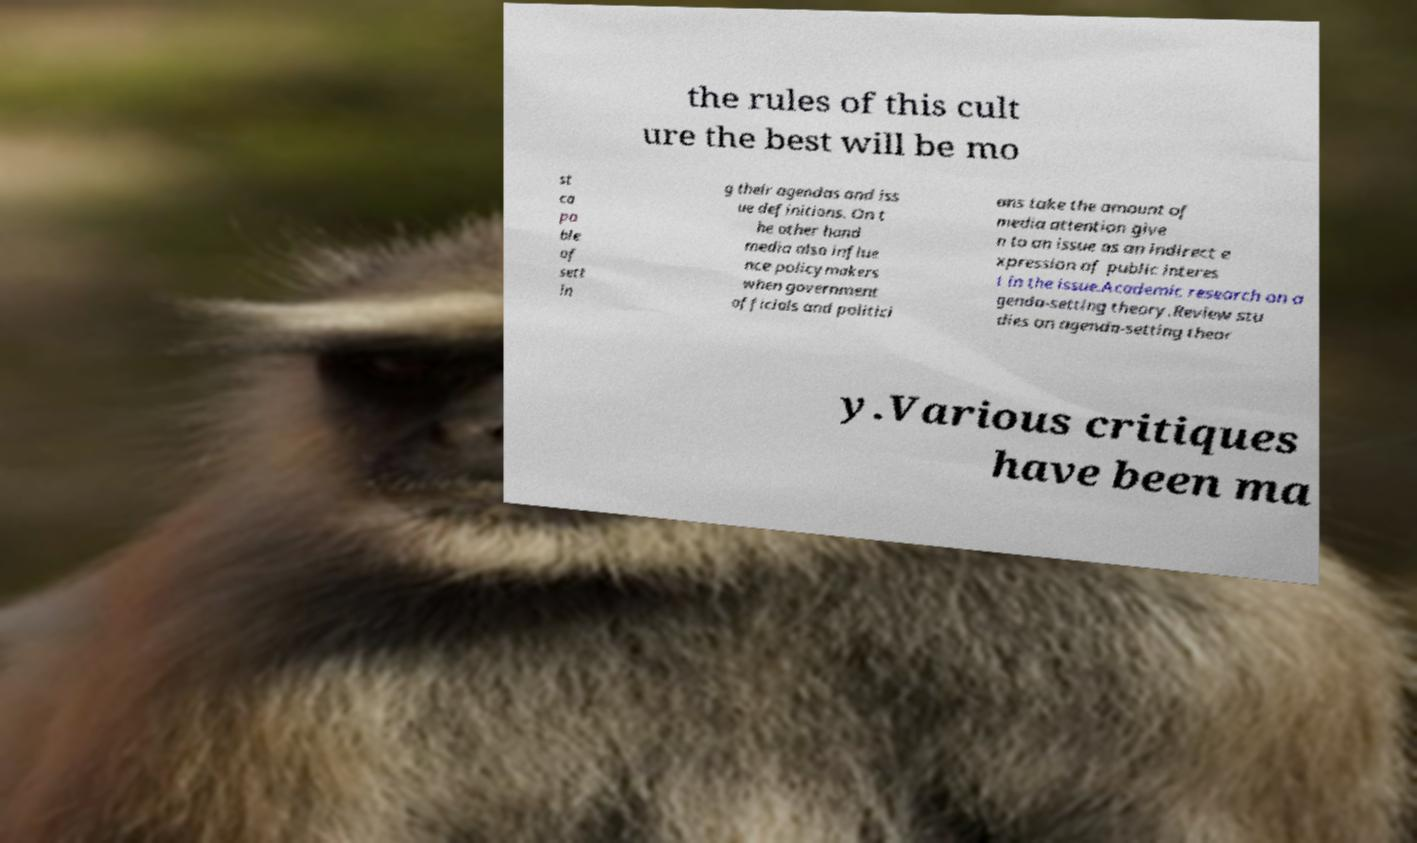Please read and relay the text visible in this image. What does it say? the rules of this cult ure the best will be mo st ca pa ble of sett in g their agendas and iss ue definitions. On t he other hand media also influe nce policymakers when government officials and politici ans take the amount of media attention give n to an issue as an indirect e xpression of public interes t in the issue.Academic research on a genda-setting theory.Review stu dies on agenda-setting theor y.Various critiques have been ma 